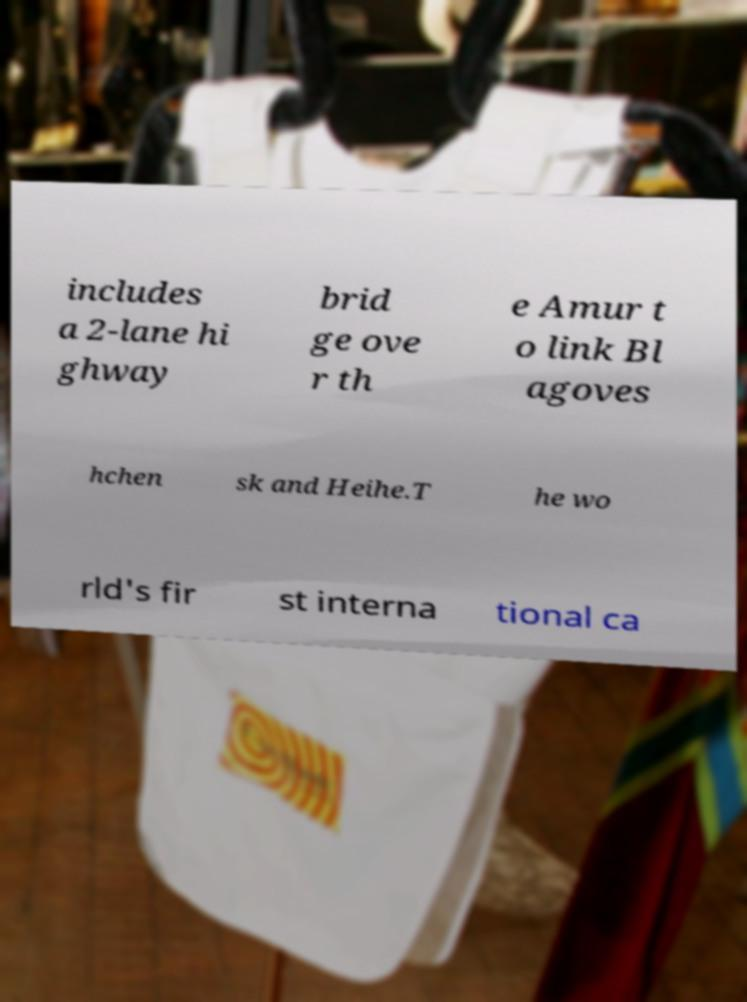Please identify and transcribe the text found in this image. includes a 2-lane hi ghway brid ge ove r th e Amur t o link Bl agoves hchen sk and Heihe.T he wo rld's fir st interna tional ca 